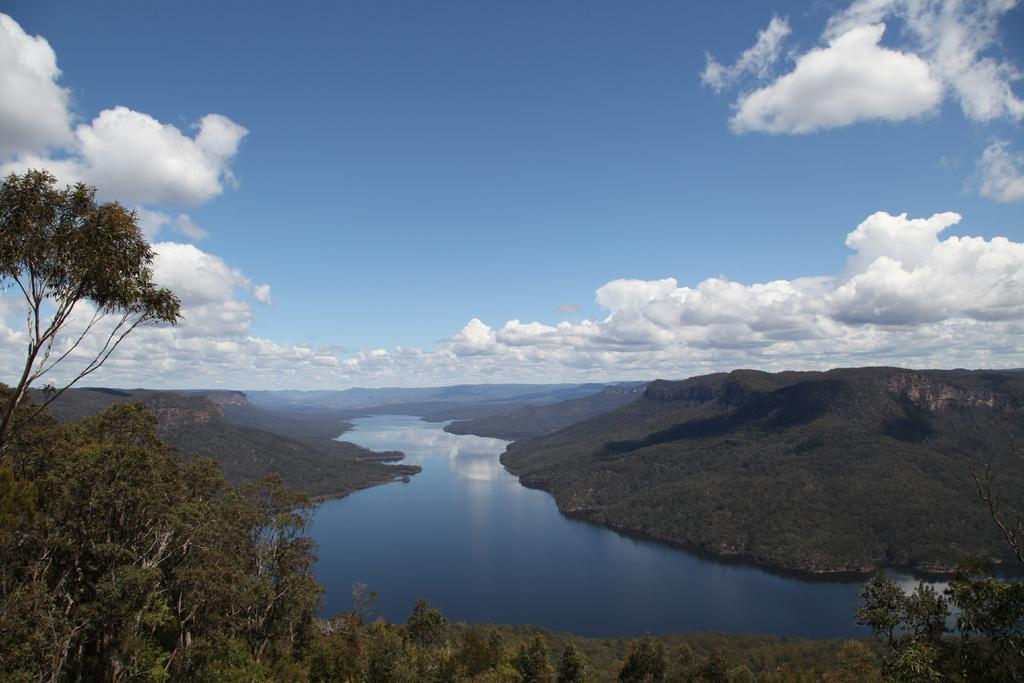What is the setting of the image? The image has an outside view. What natural feature can be seen in the image? There is a river in the image. How is the river positioned in relation to the hills? The river is situated between hills. What type of vegetation is present in the image? There are trees in the bottom left of the image. What part of the natural environment is visible in the background of the image? The sky is visible in the background of the image. Where is the branch of the meeting held in the image? There is no branch or meeting present in the image. What emotion is being expressed by the river in the image? The image does not depict emotions, as it is a natural scene featuring a river, hills, and trees. 